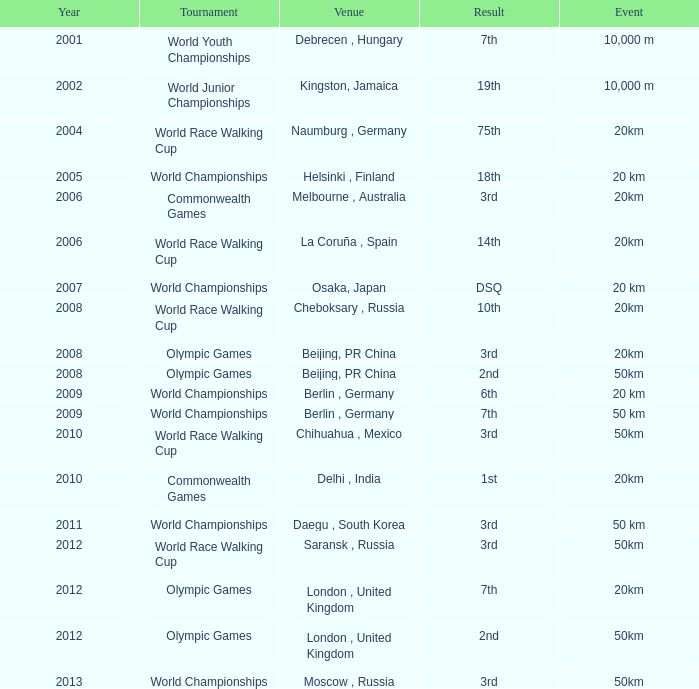When was the earliest 50km event with a second-place result conducted in london, united kingdom? 2012.0. 